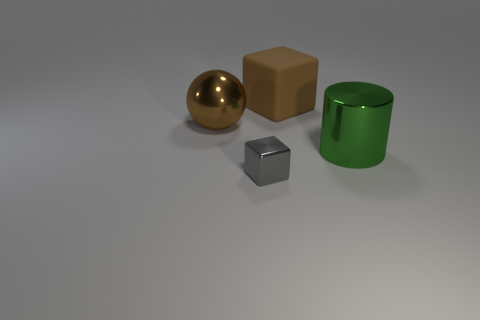Add 2 gray shiny cubes. How many objects exist? 6 Subtract all balls. How many objects are left? 3 Add 3 big metallic things. How many big metallic things are left? 5 Add 3 tiny gray shiny things. How many tiny gray shiny things exist? 4 Subtract 0 yellow cylinders. How many objects are left? 4 Subtract all brown blocks. Subtract all rubber blocks. How many objects are left? 2 